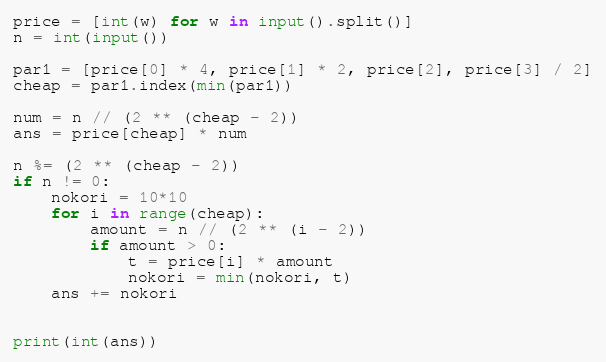Convert code to text. <code><loc_0><loc_0><loc_500><loc_500><_Python_>price = [int(w) for w in input().split()]
n = int(input())

par1 = [price[0] * 4, price[1] * 2, price[2], price[3] / 2]
cheap = par1.index(min(par1))

num = n // (2 ** (cheap - 2))
ans = price[cheap] * num

n %= (2 ** (cheap - 2))
if n != 0:
    nokori = 10*10
    for i in range(cheap):
        amount = n // (2 ** (i - 2))
        if amount > 0:
            t = price[i] * amount
            nokori = min(nokori, t)
    ans += nokori


print(int(ans))
</code> 